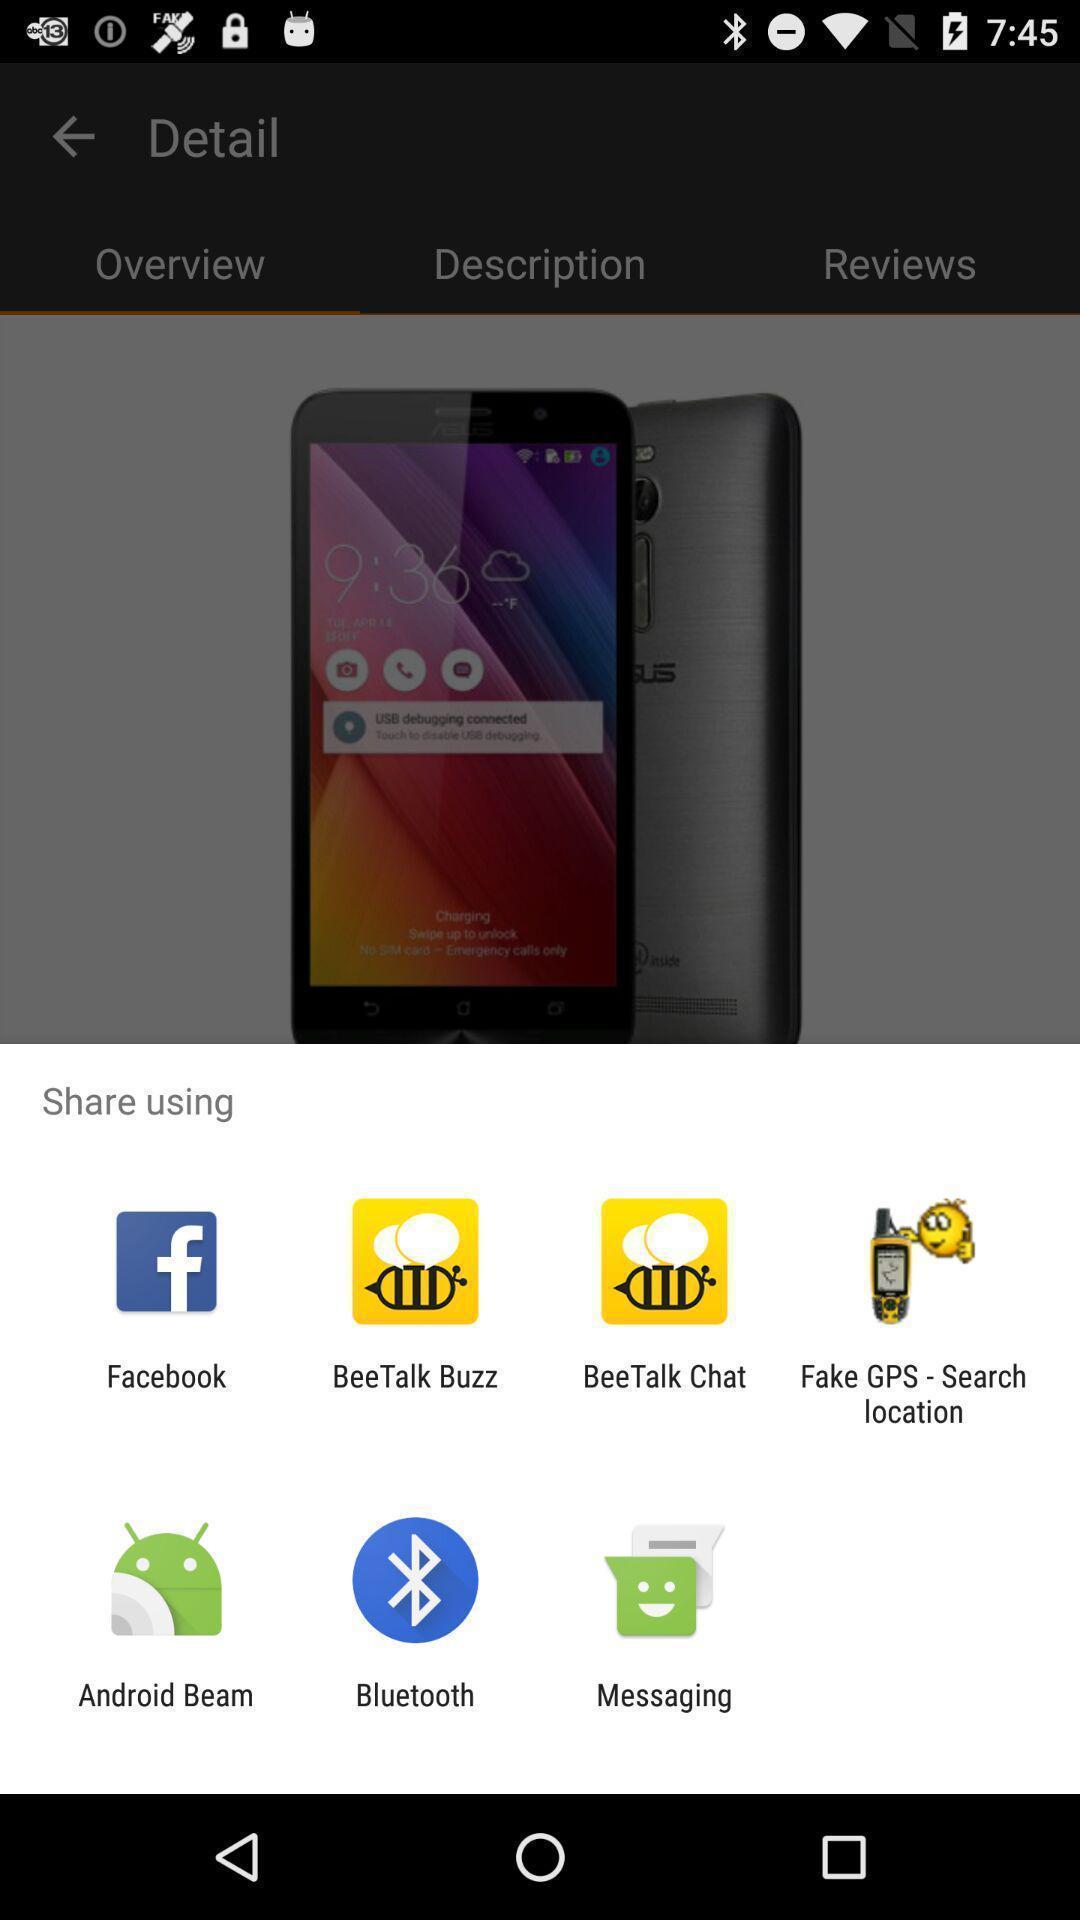Describe the content in this image. Popup of applications to share the information. 